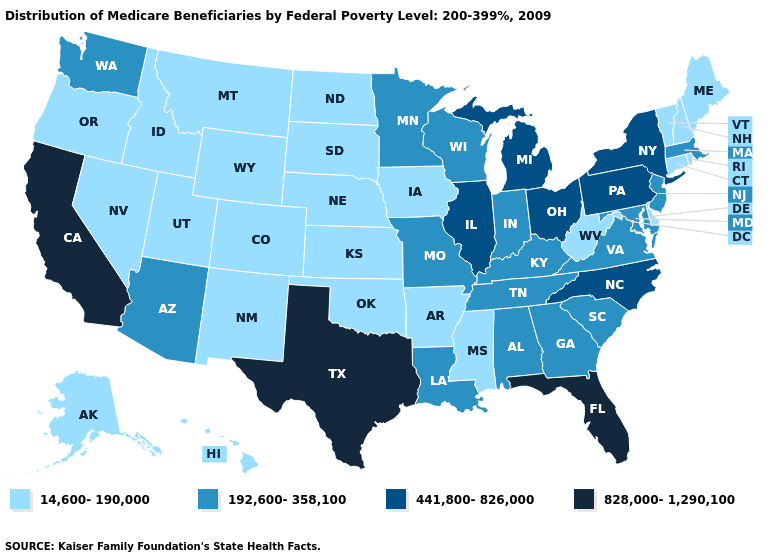Name the states that have a value in the range 14,600-190,000?
Quick response, please. Alaska, Arkansas, Colorado, Connecticut, Delaware, Hawaii, Idaho, Iowa, Kansas, Maine, Mississippi, Montana, Nebraska, Nevada, New Hampshire, New Mexico, North Dakota, Oklahoma, Oregon, Rhode Island, South Dakota, Utah, Vermont, West Virginia, Wyoming. Among the states that border California , does Arizona have the highest value?
Short answer required. Yes. Which states have the highest value in the USA?
Give a very brief answer. California, Florida, Texas. What is the lowest value in states that border Indiana?
Answer briefly. 192,600-358,100. Does the map have missing data?
Answer briefly. No. Name the states that have a value in the range 828,000-1,290,100?
Concise answer only. California, Florida, Texas. Name the states that have a value in the range 828,000-1,290,100?
Write a very short answer. California, Florida, Texas. Is the legend a continuous bar?
Write a very short answer. No. What is the lowest value in the South?
Concise answer only. 14,600-190,000. Among the states that border California , does Oregon have the lowest value?
Keep it brief. Yes. What is the lowest value in states that border Connecticut?
Concise answer only. 14,600-190,000. Does Wisconsin have the highest value in the USA?
Short answer required. No. What is the value of Nebraska?
Keep it brief. 14,600-190,000. Among the states that border Oregon , which have the lowest value?
Answer briefly. Idaho, Nevada. Among the states that border West Virginia , which have the lowest value?
Concise answer only. Kentucky, Maryland, Virginia. 